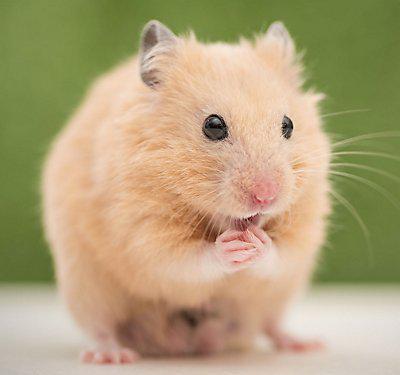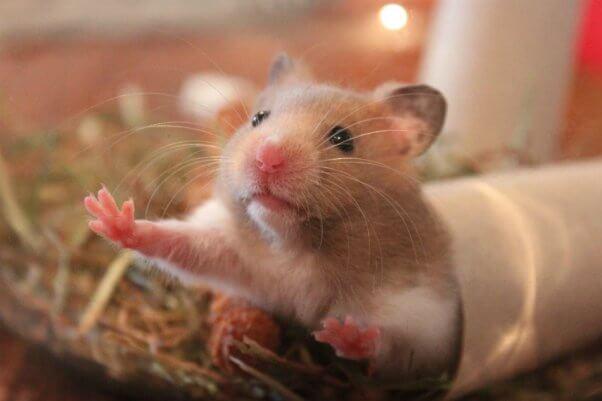The first image is the image on the left, the second image is the image on the right. Given the left and right images, does the statement "One hamster is tri-colored." hold true? Answer yes or no. No. 